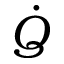Convert formula to latex. <formula><loc_0><loc_0><loc_500><loc_500>\dot { Q }</formula> 